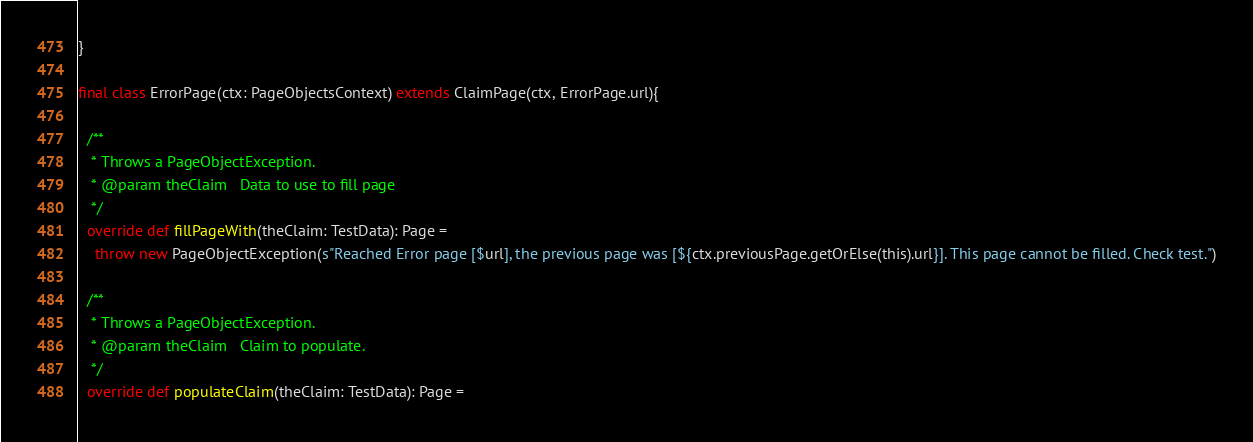Convert code to text. <code><loc_0><loc_0><loc_500><loc_500><_Scala_>}

final class ErrorPage(ctx: PageObjectsContext) extends ClaimPage(ctx, ErrorPage.url){

  /**
   * Throws a PageObjectException.
   * @param theClaim   Data to use to fill page
   */
  override def fillPageWith(theClaim: TestData): Page =
    throw new PageObjectException(s"Reached Error page [$url], the previous page was [${ctx.previousPage.getOrElse(this).url}]. This page cannot be filled. Check test.")

  /**
   * Throws a PageObjectException.
   * @param theClaim   Claim to populate.
   */
  override def populateClaim(theClaim: TestData): Page =</code> 